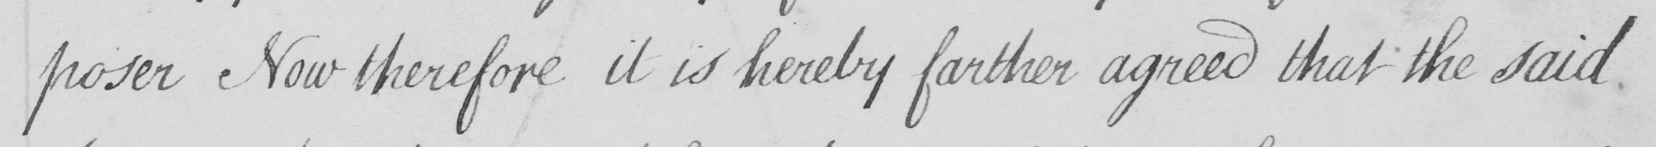Please transcribe the handwritten text in this image. -poser Now therefore it is hereby farther agreed that the said 